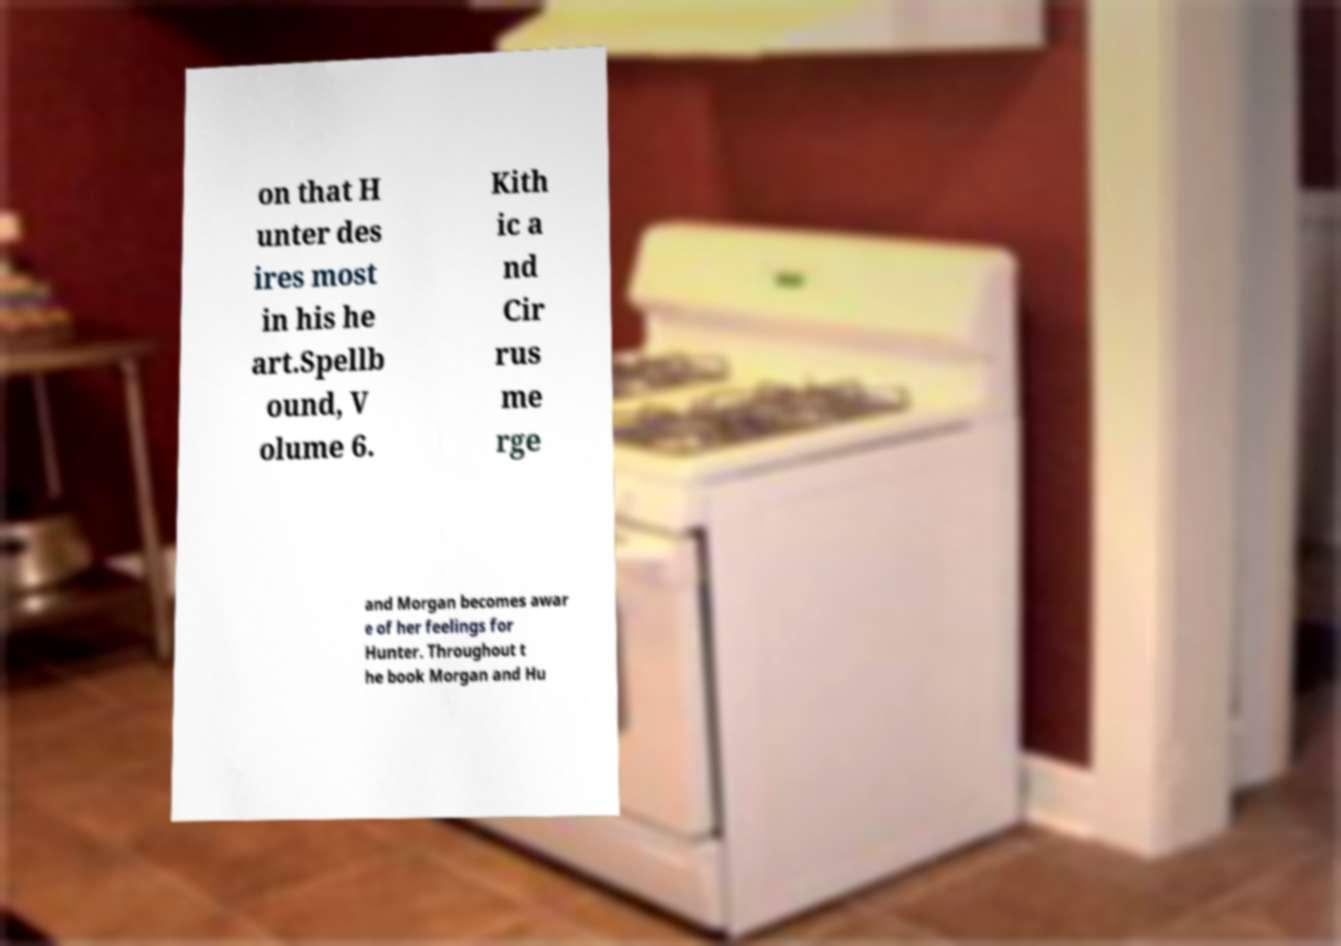Could you extract and type out the text from this image? on that H unter des ires most in his he art.Spellb ound, V olume 6. Kith ic a nd Cir rus me rge and Morgan becomes awar e of her feelings for Hunter. Throughout t he book Morgan and Hu 